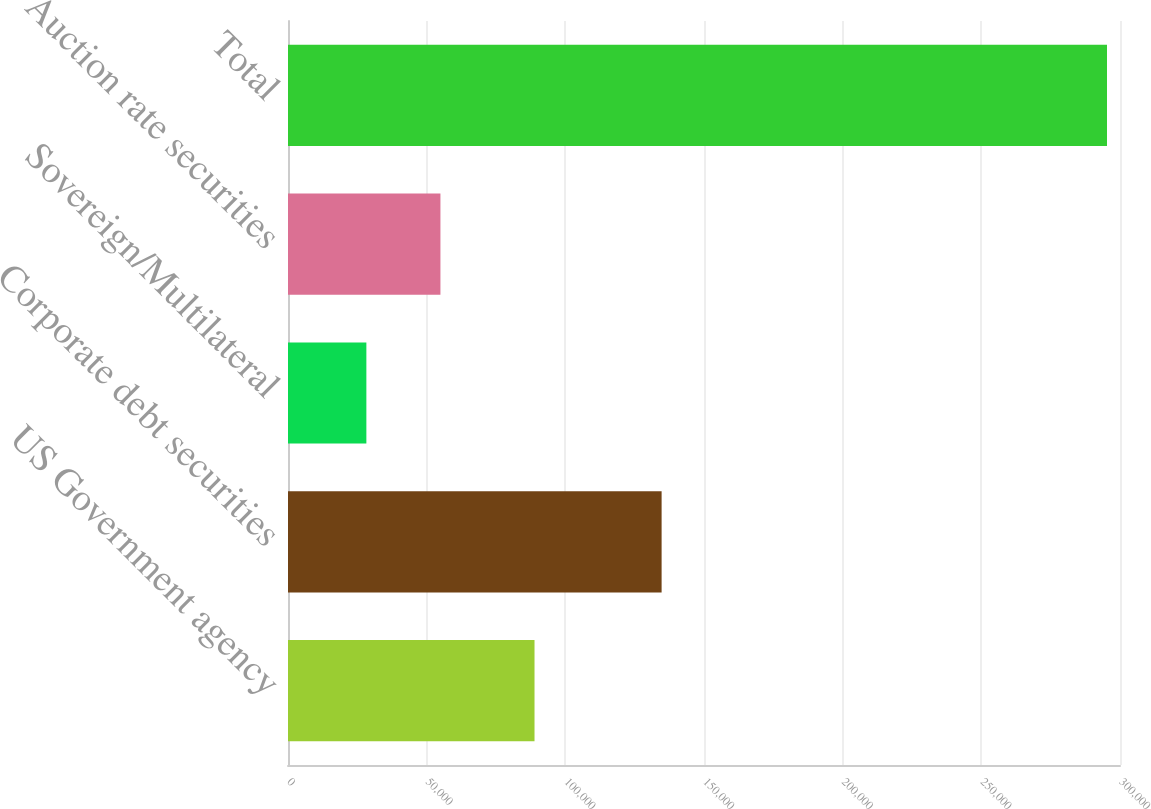Convert chart. <chart><loc_0><loc_0><loc_500><loc_500><bar_chart><fcel>US Government agency<fcel>Corporate debt securities<fcel>Sovereign/Multilateral<fcel>Auction rate securities<fcel>Total<nl><fcel>88888<fcel>134716<fcel>28258<fcel>54963.4<fcel>295312<nl></chart> 